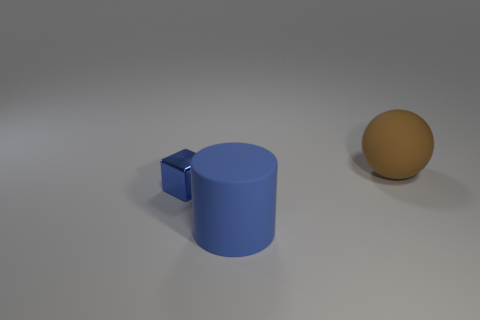Add 1 big red objects. How many objects exist? 4 Subtract all spheres. How many objects are left? 2 Subtract 0 gray balls. How many objects are left? 3 Subtract all big blue rubber cylinders. Subtract all brown balls. How many objects are left? 1 Add 1 brown things. How many brown things are left? 2 Add 1 tiny cyan rubber balls. How many tiny cyan rubber balls exist? 1 